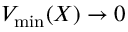<formula> <loc_0><loc_0><loc_500><loc_500>V _ { \min } ( X ) \to 0</formula> 